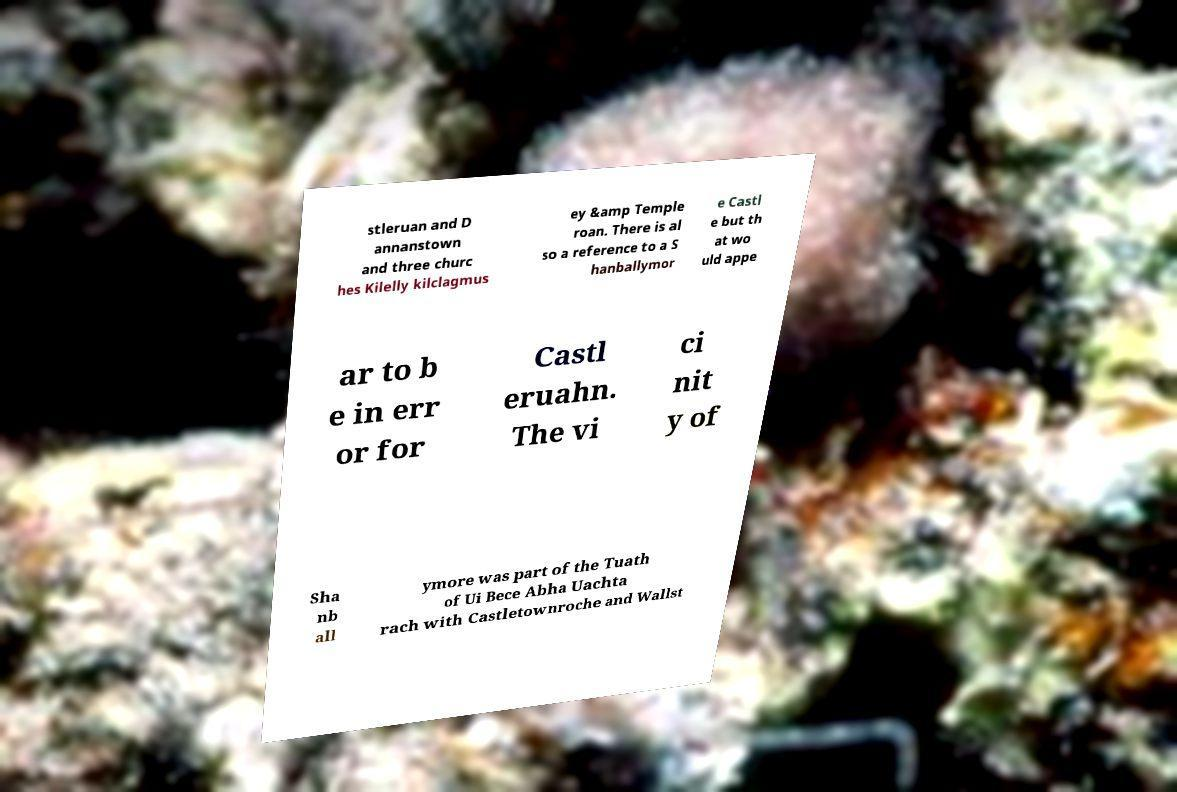Can you read and provide the text displayed in the image?This photo seems to have some interesting text. Can you extract and type it out for me? stleruan and D annanstown and three churc hes Kilelly kilclagmus ey &amp Temple roan. There is al so a reference to a S hanballymor e Castl e but th at wo uld appe ar to b e in err or for Castl eruahn. The vi ci nit y of Sha nb all ymore was part of the Tuath of Ui Bece Abha Uachta rach with Castletownroche and Wallst 